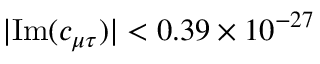<formula> <loc_0><loc_0><loc_500><loc_500>| I m ( c _ { \mu \tau } ) | < 0 . 3 9 \times 1 0 ^ { - 2 7 }</formula> 